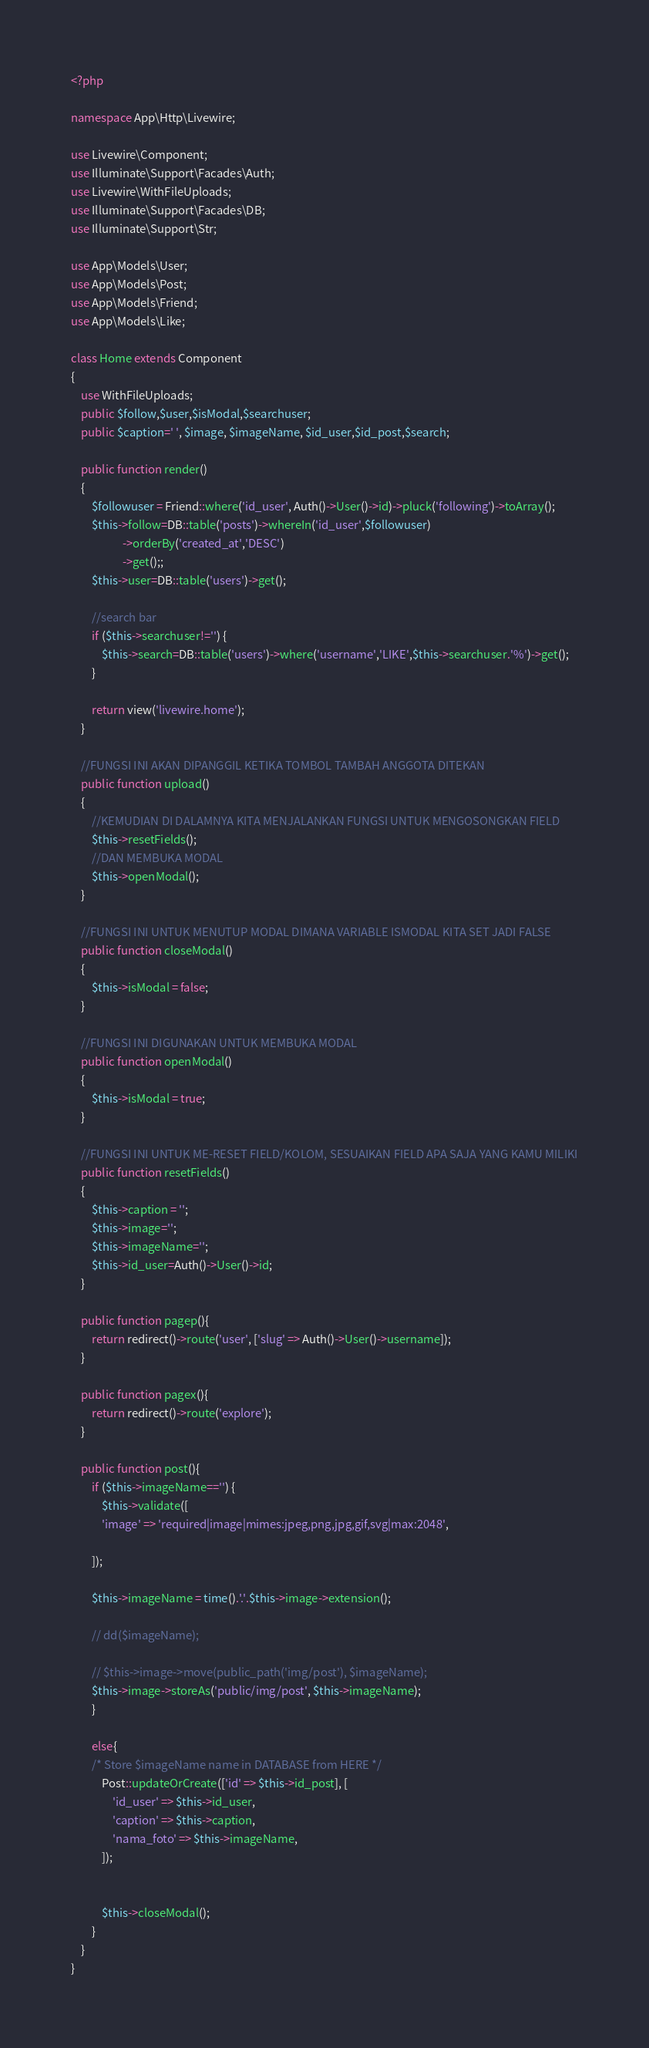<code> <loc_0><loc_0><loc_500><loc_500><_PHP_><?php

namespace App\Http\Livewire;

use Livewire\Component;
use Illuminate\Support\Facades\Auth;
use Livewire\WithFileUploads;
use Illuminate\Support\Facades\DB;
use Illuminate\Support\Str;

use App\Models\User;
use App\Models\Post;
use App\Models\Friend;
use App\Models\Like;

class Home extends Component
{
    use WithFileUploads;
	public $follow,$user,$isModal,$searchuser;
    public $caption=' ', $image, $imageName, $id_user,$id_post,$search;

    public function render()
    {   
        $followuser = Friend::where('id_user', Auth()->User()->id)->pluck('following')->toArray();
        $this->follow=DB::table('posts')->whereIn('id_user',$followuser)
                    ->orderBy('created_at','DESC')
                    ->get();;
        $this->user=DB::table('users')->get();

        //search bar
        if ($this->searchuser!='') {
            $this->search=DB::table('users')->where('username','LIKE',$this->searchuser.'%')->get();
        }
        
        return view('livewire.home');
    }

    //FUNGSI INI AKAN DIPANGGIL KETIKA TOMBOL TAMBAH ANGGOTA DITEKAN
    public function upload()
    {
        //KEMUDIAN DI DALAMNYA KITA MENJALANKAN FUNGSI UNTUK MENGOSONGKAN FIELD
        $this->resetFields();
        //DAN MEMBUKA MODAL
        $this->openModal();
    }

    //FUNGSI INI UNTUK MENUTUP MODAL DIMANA VARIABLE ISMODAL KITA SET JADI FALSE
    public function closeModal()
    {
        $this->isModal = false;
    }

    //FUNGSI INI DIGUNAKAN UNTUK MEMBUKA MODAL
    public function openModal()
    {
        $this->isModal = true;
    }

    //FUNGSI INI UNTUK ME-RESET FIELD/KOLOM, SESUAIKAN FIELD APA SAJA YANG KAMU MILIKI
    public function resetFields()
    {
        $this->caption = '';
        $this->image='';
        $this->imageName='';
        $this->id_user=Auth()->User()->id;
    }

    public function pagep(){
        return redirect()->route('user', ['slug' => Auth()->User()->username]);
    }

    public function pagex(){
        return redirect()->route('explore');
    }

    public function post(){
        if ($this->imageName=='') {
            $this->validate([
            'image' => 'required|image|mimes:jpeg,png,jpg,gif,svg|max:2048',

        ]);

        $this->imageName = time().'.'.$this->image->extension();  

        // dd($imageName);

        // $this->image->move(public_path('img/post'), $imageName);
        $this->image->storeAs('public/img/post', $this->imageName);    
        }
        
        else{
        /* Store $imageName name in DATABASE from HERE */
            Post::updateOrCreate(['id' => $this->id_post], [
                'id_user' => $this->id_user,
                'caption' => $this->caption,
                'nama_foto' => $this->imageName,
            ]);

        
            $this->closeModal();
        }
    }
}</code> 